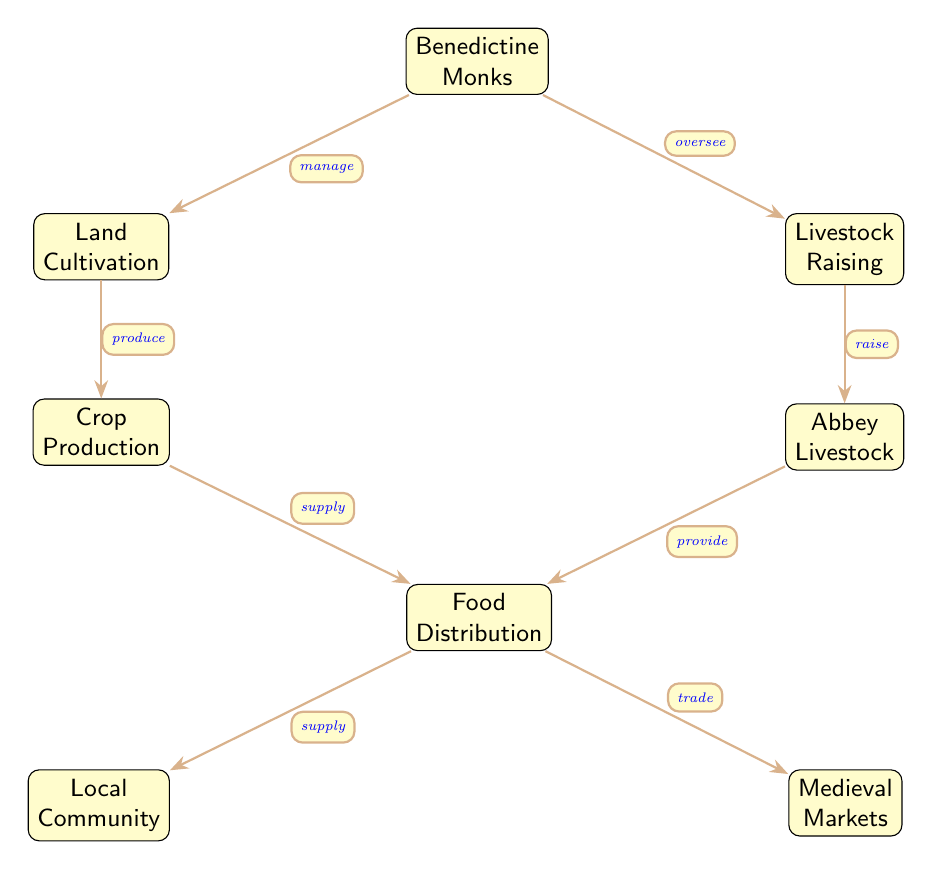What is the role of Benedictine Monks in the diagram? The diagram shows that the Benedictine Monks manage land cultivation and oversee livestock raising. Therefore, their primary role is to provide guidance and direction for agricultural activities.
Answer: manage, oversee How many nodes are present in the diagram? The diagram consists of a total of eight nodes representing different elements of monastic agriculture. These include Benedictine Monks, Land Cultivation, Livestock Raising, Crop Production, Abbey Livestock, Food Distribution, Local Community, and Medieval Markets.
Answer: 8 What does Land Cultivation produce? According to the diagram, Land Cultivation leads to the production of Crop Production. The connection indicates that once land is cultivated, it results in crops being produced.
Answer: Crop Production What is the relationship between Crop Production and Food Distribution? The relationship is that Crop Production supplies Food Distribution, as indicated by the arrow showing flow from Crop Production to Food Distribution. The crops produced are directed towards distribution.
Answer: supply Which node represents the community that benefits from the food produced? The Local Community node represents the group that benefits from the food produced, as its position shows it receives supplies from the Food Distribution node.
Answer: Local Community How do Abbey Livestock contribute to Food Distribution? Abbey Livestock provide food to Food Distribution, as illustrated by the directed edge from Abbey Livestock to Food Distribution, indicating their direct contribution to the food supply.
Answer: provide Where do the food products from the Food Distribution go after being supplied? The food products are supplied to both the Local Community and Medieval Markets, as indicated by the edges branching out from the Food Distribution node.
Answer: Local Community, Medieval Markets What type of farming do Benedictine Monks oversee? The diagram specifies that the Benedictine Monks oversee Livestock Raising, indicating their role in managing livestock as part of agricultural activities.
Answer: Livestock Raising In the diagram, how many paths lead from Food Distribution? There are two paths that lead from Food Distribution, one to Local Community and another to Medieval Markets, indicating two avenues of distribution for food produced.
Answer: 2 